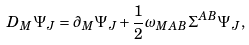<formula> <loc_0><loc_0><loc_500><loc_500>D _ { M } \Psi _ { J } = \partial _ { M } \Psi _ { J } + \frac { 1 } { 2 } \omega _ { M A B } \Sigma ^ { A B } \Psi _ { J } ,</formula> 